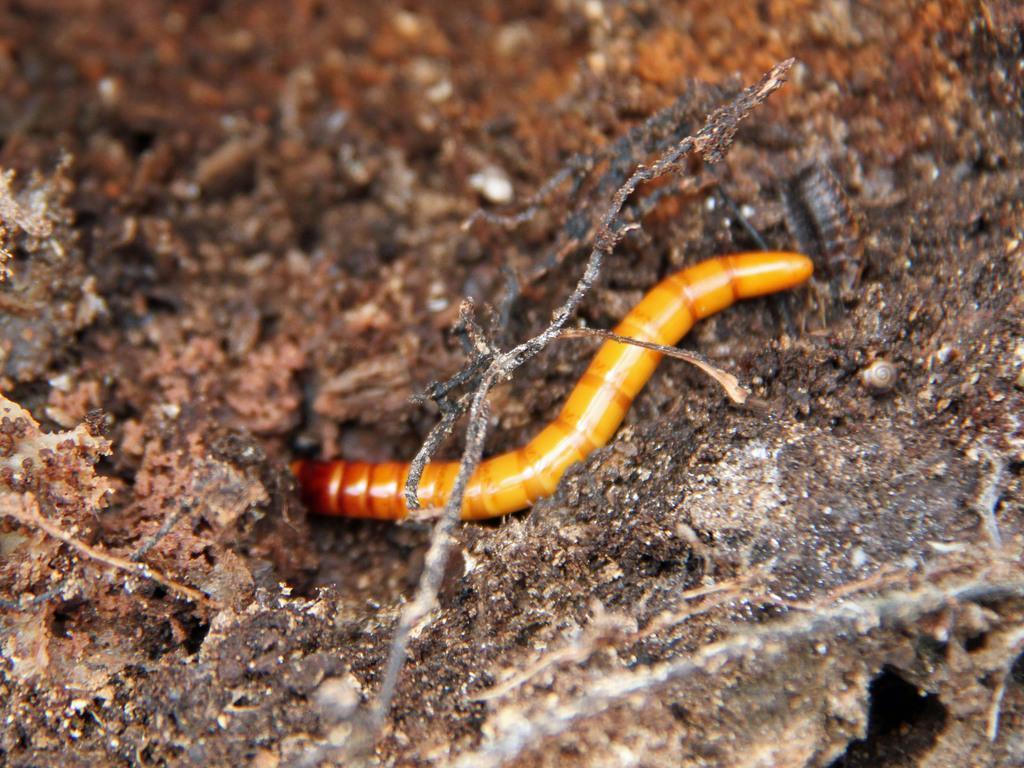Describe this image in one or two sentences. In this image, we can see worm in the ground. 